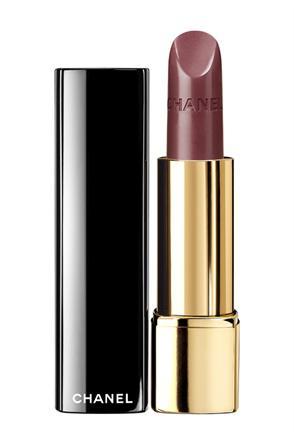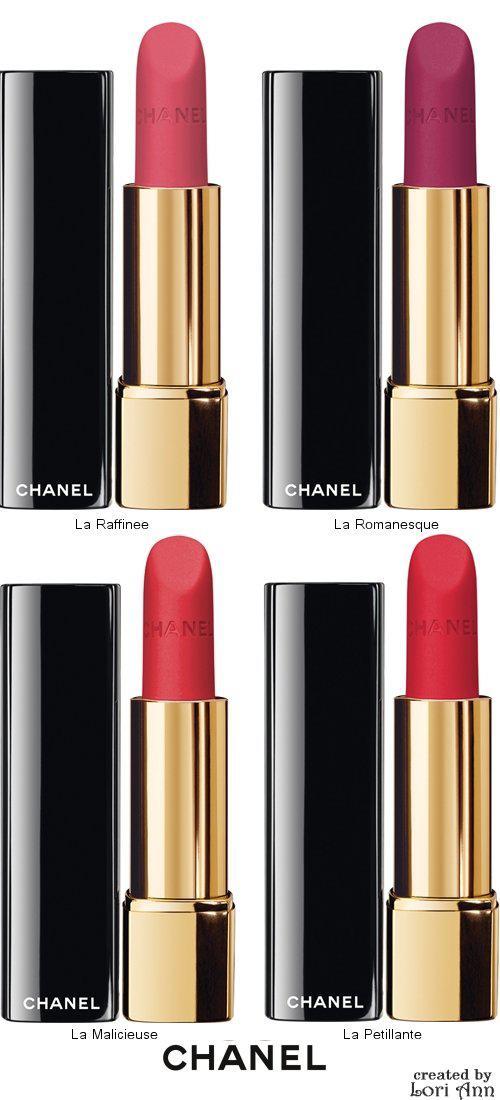The first image is the image on the left, the second image is the image on the right. For the images shown, is this caption "One image contains a single lipstick next to its lid, and the other image contains multiple lipsticks next to their lids." true? Answer yes or no. Yes. The first image is the image on the left, the second image is the image on the right. Evaluate the accuracy of this statement regarding the images: "There are more than one lipsticks in one of the images.". Is it true? Answer yes or no. Yes. 